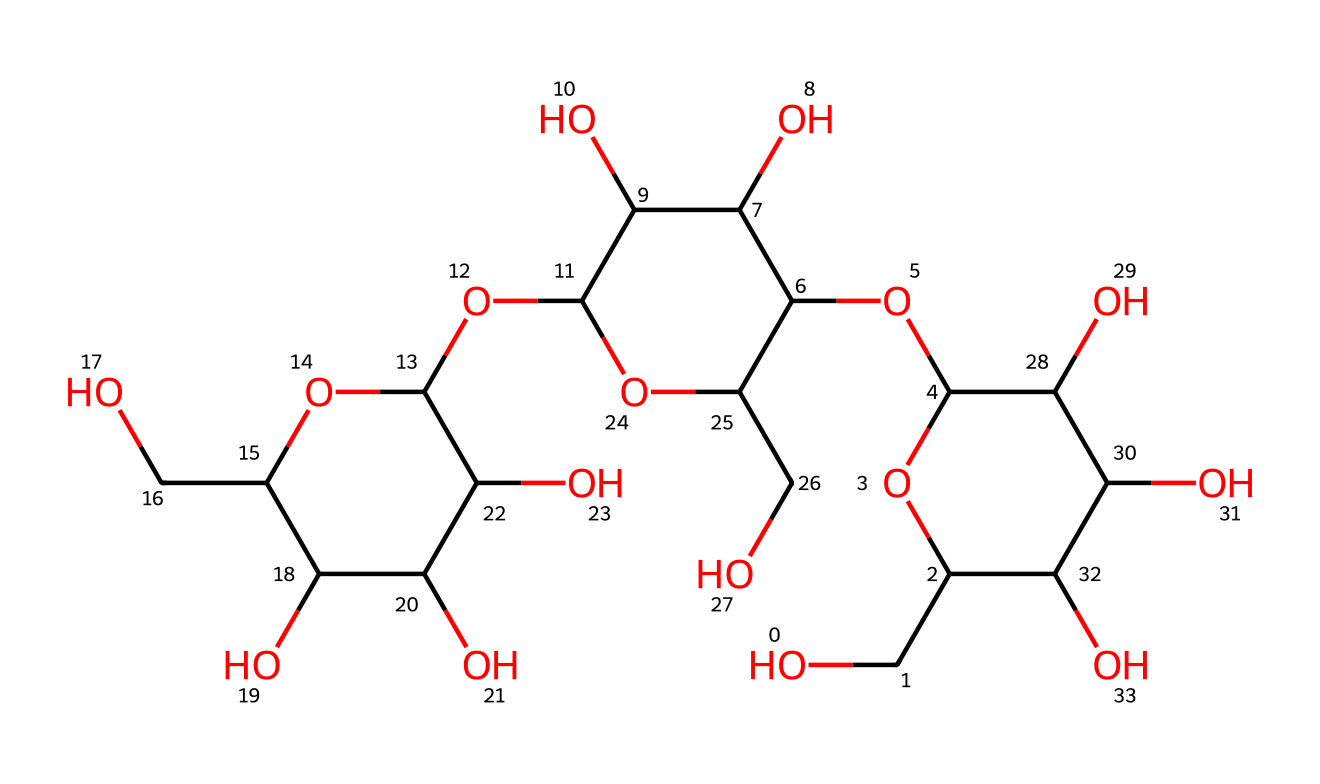What type of carbohydrate is represented by this chemical structure? The chemical structure suggests the presence of multiple hydroxyl (-OH) groups and a backbone typical of polysaccharides, indicating it is a polysaccharide.
Answer: polysaccharide How many carbon atoms are in the chemical structure? By examining the structure and counting the carbon atoms shown in the SMILES representation, we find that there are 30 carbon atoms.
Answer: 30 What is the primary functional group in this chemical? The presence of multiple hydroxyl (-OH) groups indicates that the primary functional group involved in this chemical is alcohol.
Answer: alcohol How many oxygens are present in this compound? By counting the oxygen atoms in the chemical structure, we find a total of 12 oxygen atoms.
Answer: 12 Does this fiber exhibit properties similar to cellulose? The chemical structure shares characteristics with cellulose due to its polysaccharide nature and similar functional groups, suggesting it does exhibit similar properties.
Answer: yes What is the main use of linen fibers derived from this chemical structure? Linen fibers, like those represented by this structure, are primarily used in fabric and textile applications due to their strength, durability, and absorbency.
Answer: fabric 